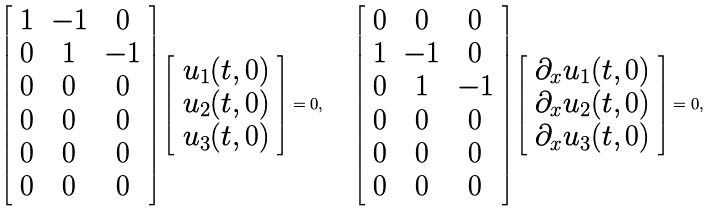Convert formula to latex. <formula><loc_0><loc_0><loc_500><loc_500>\left [ \begin{array} { c c c } 1 & - 1 & 0 \\ 0 & 1 & - 1 \\ 0 & 0 & 0 \\ 0 & 0 & 0 \\ 0 & 0 & 0 \\ 0 & 0 & 0 \end{array} \right ] \left [ \begin{array} { r } u _ { 1 } ( t , 0 ) \\ u _ { 2 } ( t , 0 ) \\ u _ { 3 } ( t , 0 ) \end{array} \right ] = 0 , \quad \left [ \begin{array} { c c c } 0 & 0 & 0 \\ 1 & - 1 & 0 \\ 0 & 1 & - 1 \\ 0 & 0 & 0 \\ 0 & 0 & 0 \\ 0 & 0 & 0 \\ \end{array} \right ] \left [ \begin{array} { r } \partial _ { x } u _ { 1 } ( t , 0 ) \\ \partial _ { x } u _ { 2 } ( t , 0 ) \\ \partial _ { x } u _ { 3 } ( t , 0 ) \end{array} \right ] = 0 ,</formula> 